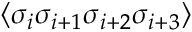Convert formula to latex. <formula><loc_0><loc_0><loc_500><loc_500>\langle \sigma _ { i } \sigma _ { i + 1 } \sigma _ { i + 2 } \sigma _ { i + 3 } \rangle</formula> 